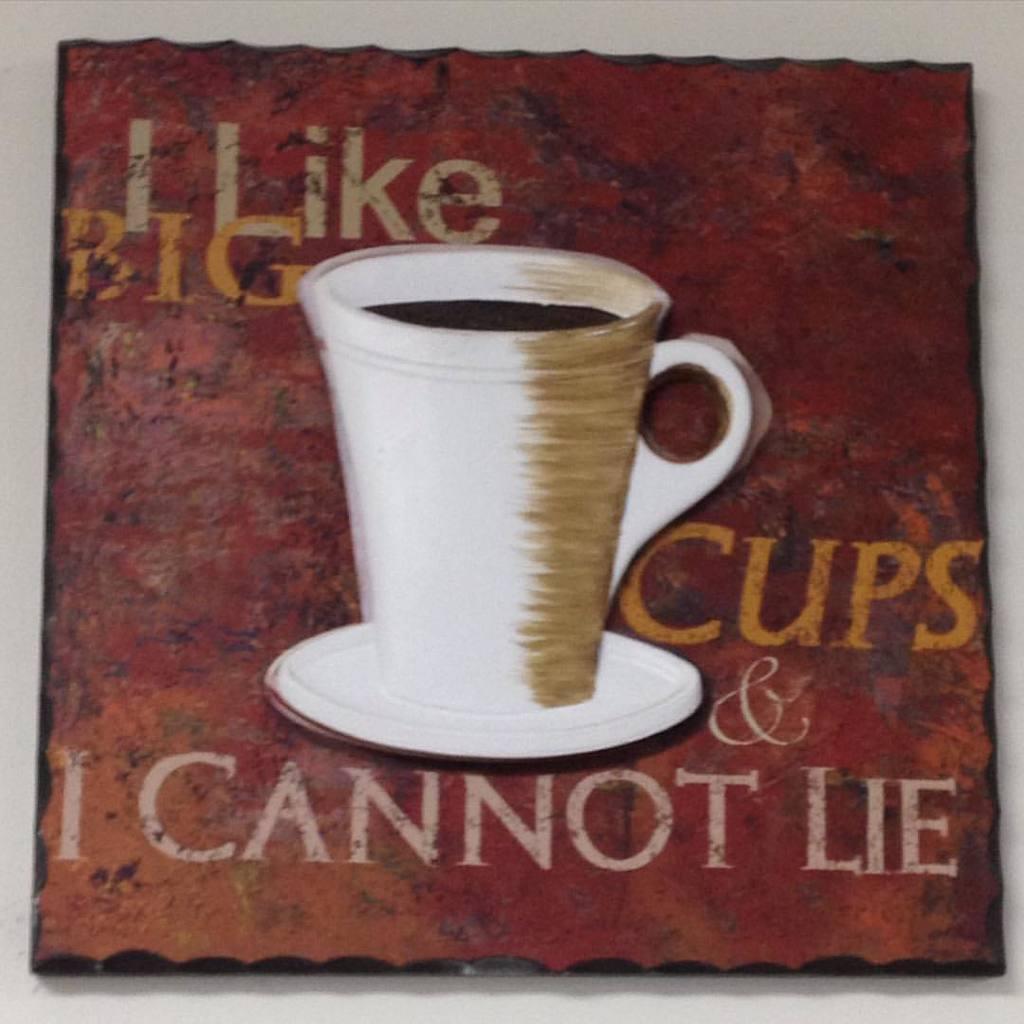What does this picture imply they like?
Your response must be concise. Big cups. What does the sign say he can't do?
Make the answer very short. Lie. 